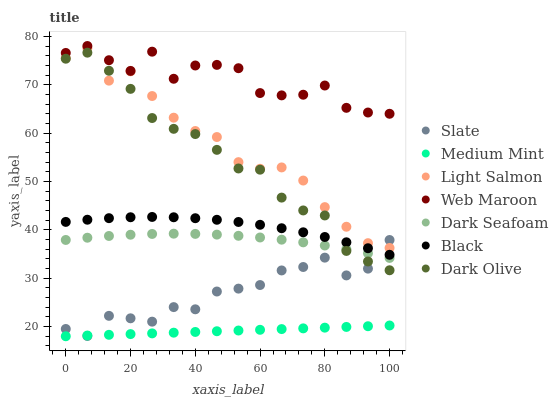Does Medium Mint have the minimum area under the curve?
Answer yes or no. Yes. Does Web Maroon have the maximum area under the curve?
Answer yes or no. Yes. Does Light Salmon have the minimum area under the curve?
Answer yes or no. No. Does Light Salmon have the maximum area under the curve?
Answer yes or no. No. Is Medium Mint the smoothest?
Answer yes or no. Yes. Is Web Maroon the roughest?
Answer yes or no. Yes. Is Light Salmon the smoothest?
Answer yes or no. No. Is Light Salmon the roughest?
Answer yes or no. No. Does Medium Mint have the lowest value?
Answer yes or no. Yes. Does Light Salmon have the lowest value?
Answer yes or no. No. Does Web Maroon have the highest value?
Answer yes or no. Yes. Does Light Salmon have the highest value?
Answer yes or no. No. Is Light Salmon less than Web Maroon?
Answer yes or no. Yes. Is Black greater than Medium Mint?
Answer yes or no. Yes. Does Dark Olive intersect Black?
Answer yes or no. Yes. Is Dark Olive less than Black?
Answer yes or no. No. Is Dark Olive greater than Black?
Answer yes or no. No. Does Light Salmon intersect Web Maroon?
Answer yes or no. No. 